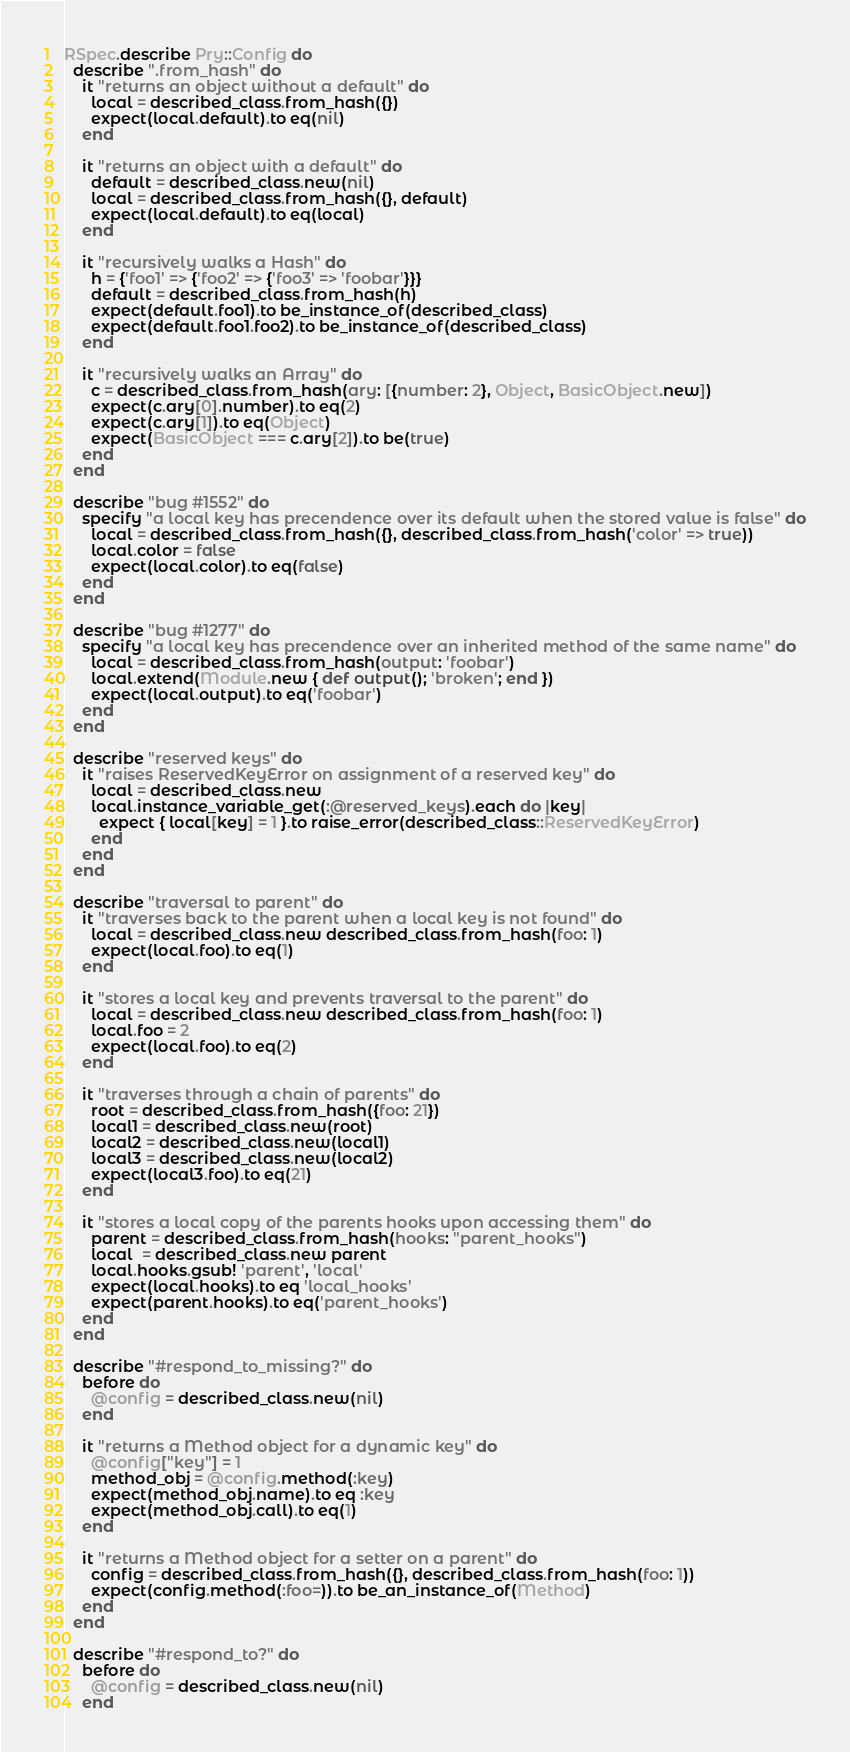Convert code to text. <code><loc_0><loc_0><loc_500><loc_500><_Ruby_>RSpec.describe Pry::Config do
  describe ".from_hash" do
    it "returns an object without a default" do
      local = described_class.from_hash({})
      expect(local.default).to eq(nil)
    end

    it "returns an object with a default" do
      default = described_class.new(nil)
      local = described_class.from_hash({}, default)
      expect(local.default).to eq(local)
    end

    it "recursively walks a Hash" do
      h = {'foo1' => {'foo2' => {'foo3' => 'foobar'}}}
      default = described_class.from_hash(h)
      expect(default.foo1).to be_instance_of(described_class)
      expect(default.foo1.foo2).to be_instance_of(described_class)
    end

    it "recursively walks an Array" do
      c = described_class.from_hash(ary: [{number: 2}, Object, BasicObject.new])
      expect(c.ary[0].number).to eq(2)
      expect(c.ary[1]).to eq(Object)
      expect(BasicObject === c.ary[2]).to be(true)
    end
  end

  describe "bug #1552" do
    specify "a local key has precendence over its default when the stored value is false" do
      local = described_class.from_hash({}, described_class.from_hash('color' => true))
      local.color = false
      expect(local.color).to eq(false)
    end
  end

  describe "bug #1277" do
    specify "a local key has precendence over an inherited method of the same name" do
      local = described_class.from_hash(output: 'foobar')
      local.extend(Module.new { def output(); 'broken'; end })
      expect(local.output).to eq('foobar')
    end
  end

  describe "reserved keys" do
    it "raises ReservedKeyError on assignment of a reserved key" do
      local = described_class.new
      local.instance_variable_get(:@reserved_keys).each do |key|
        expect { local[key] = 1 }.to raise_error(described_class::ReservedKeyError)
      end
    end
  end

  describe "traversal to parent" do
    it "traverses back to the parent when a local key is not found" do
      local = described_class.new described_class.from_hash(foo: 1)
      expect(local.foo).to eq(1)
    end

    it "stores a local key and prevents traversal to the parent" do
      local = described_class.new described_class.from_hash(foo: 1)
      local.foo = 2
      expect(local.foo).to eq(2)
    end

    it "traverses through a chain of parents" do
      root = described_class.from_hash({foo: 21})
      local1 = described_class.new(root)
      local2 = described_class.new(local1)
      local3 = described_class.new(local2)
      expect(local3.foo).to eq(21)
    end

    it "stores a local copy of the parents hooks upon accessing them" do
      parent = described_class.from_hash(hooks: "parent_hooks")
      local  = described_class.new parent
      local.hooks.gsub! 'parent', 'local'
      expect(local.hooks).to eq 'local_hooks'
      expect(parent.hooks).to eq('parent_hooks')
    end
  end

  describe "#respond_to_missing?" do
    before do
      @config = described_class.new(nil)
    end

    it "returns a Method object for a dynamic key" do
      @config["key"] = 1
      method_obj = @config.method(:key)
      expect(method_obj.name).to eq :key
      expect(method_obj.call).to eq(1)
    end

    it "returns a Method object for a setter on a parent" do
      config = described_class.from_hash({}, described_class.from_hash(foo: 1))
      expect(config.method(:foo=)).to be_an_instance_of(Method)
    end
  end

  describe "#respond_to?" do
    before do
      @config = described_class.new(nil)
    end
</code> 